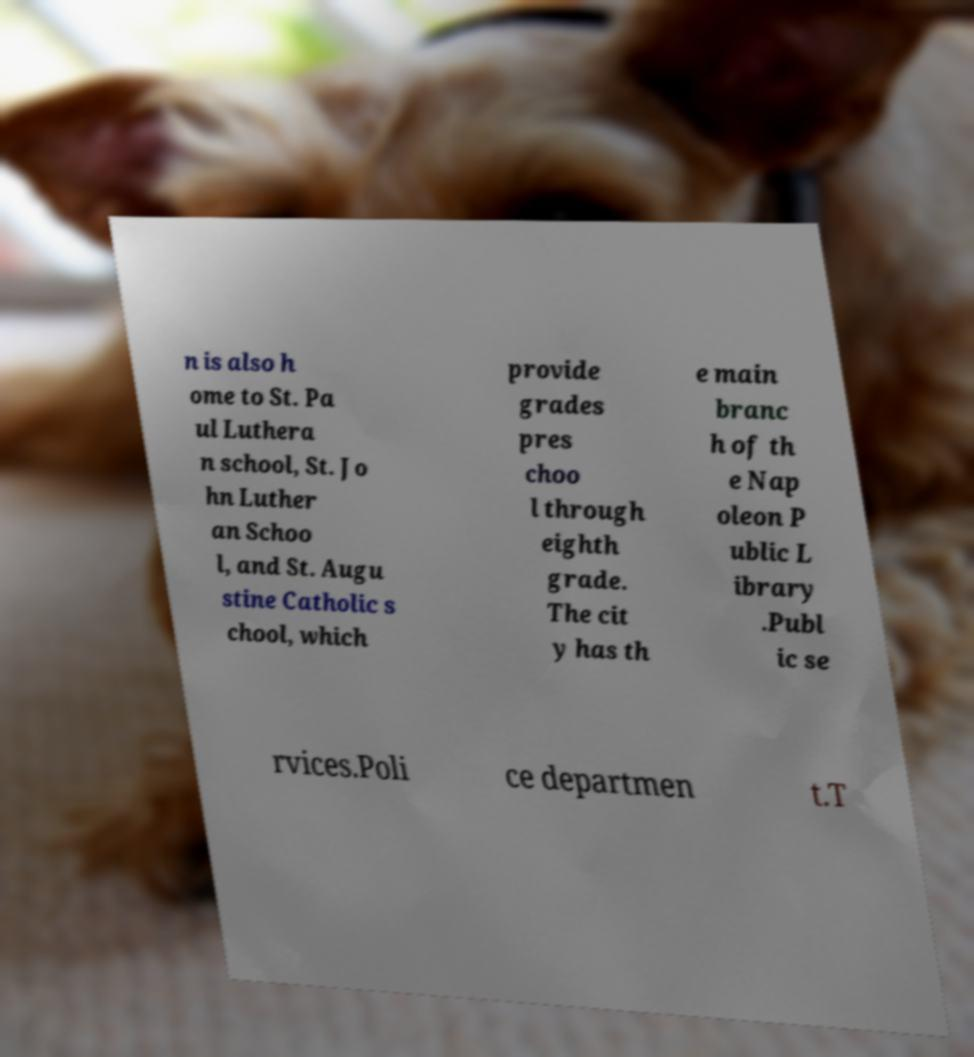What messages or text are displayed in this image? I need them in a readable, typed format. n is also h ome to St. Pa ul Luthera n school, St. Jo hn Luther an Schoo l, and St. Augu stine Catholic s chool, which provide grades pres choo l through eighth grade. The cit y has th e main branc h of th e Nap oleon P ublic L ibrary .Publ ic se rvices.Poli ce departmen t.T 